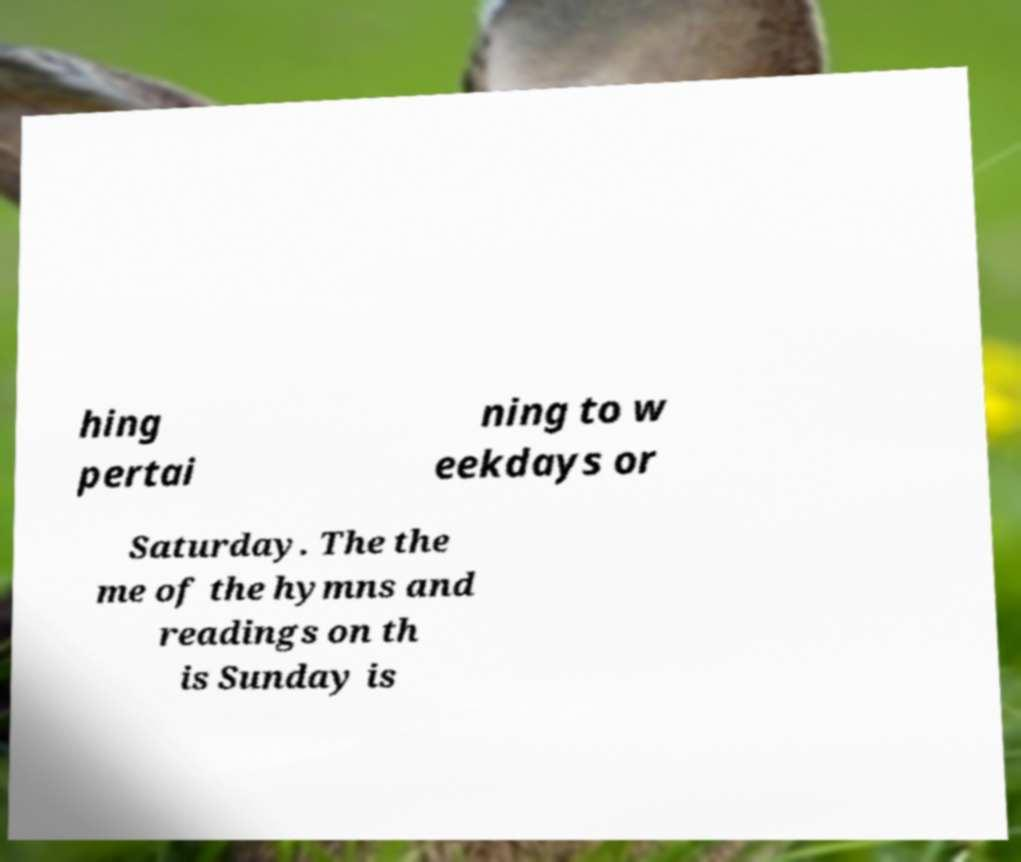Please identify and transcribe the text found in this image. hing pertai ning to w eekdays or Saturday. The the me of the hymns and readings on th is Sunday is 